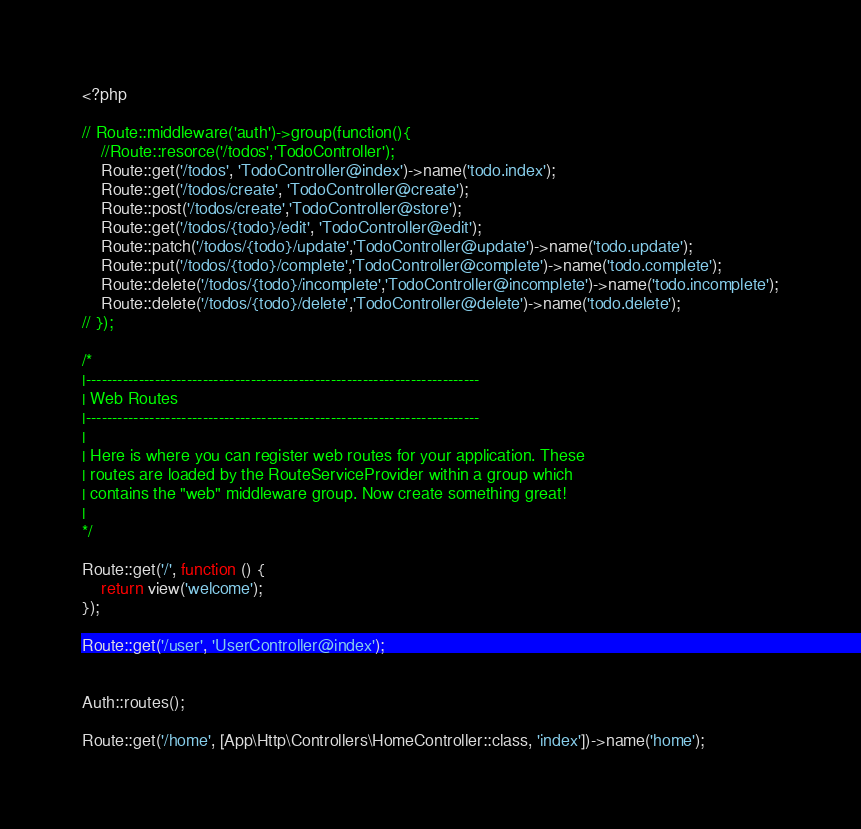Convert code to text. <code><loc_0><loc_0><loc_500><loc_500><_PHP_><?php

// Route::middleware('auth')->group(function(){
    //Route::resorce('/todos','TodoController');
    Route::get('/todos', 'TodoController@index')->name('todo.index');
    Route::get('/todos/create', 'TodoController@create');
    Route::post('/todos/create','TodoController@store');
    Route::get('/todos/{todo}/edit', 'TodoController@edit');
    Route::patch('/todos/{todo}/update','TodoController@update')->name('todo.update');
    Route::put('/todos/{todo}/complete','TodoController@complete')->name('todo.complete');
    Route::delete('/todos/{todo}/incomplete','TodoController@incomplete')->name('todo.incomplete');
    Route::delete('/todos/{todo}/delete','TodoController@delete')->name('todo.delete');
// });

/*
|--------------------------------------------------------------------------
| Web Routes
|--------------------------------------------------------------------------
|
| Here is where you can register web routes for your application. These
| routes are loaded by the RouteServiceProvider within a group which
| contains the "web" middleware group. Now create something great!
|
*/

Route::get('/', function () {
    return view('welcome');
});

Route::get('/user', 'UserController@index');


Auth::routes();

Route::get('/home', [App\Http\Controllers\HomeController::class, 'index'])->name('home');
</code> 